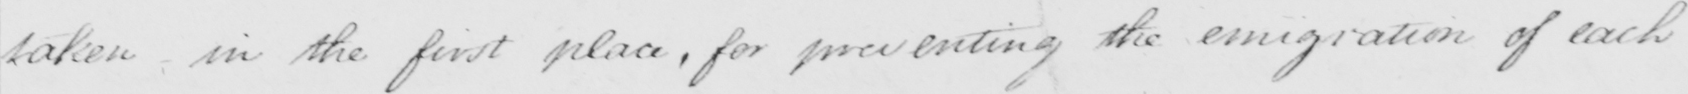Please provide the text content of this handwritten line. taken in the first place, for preventing the emigration of each 